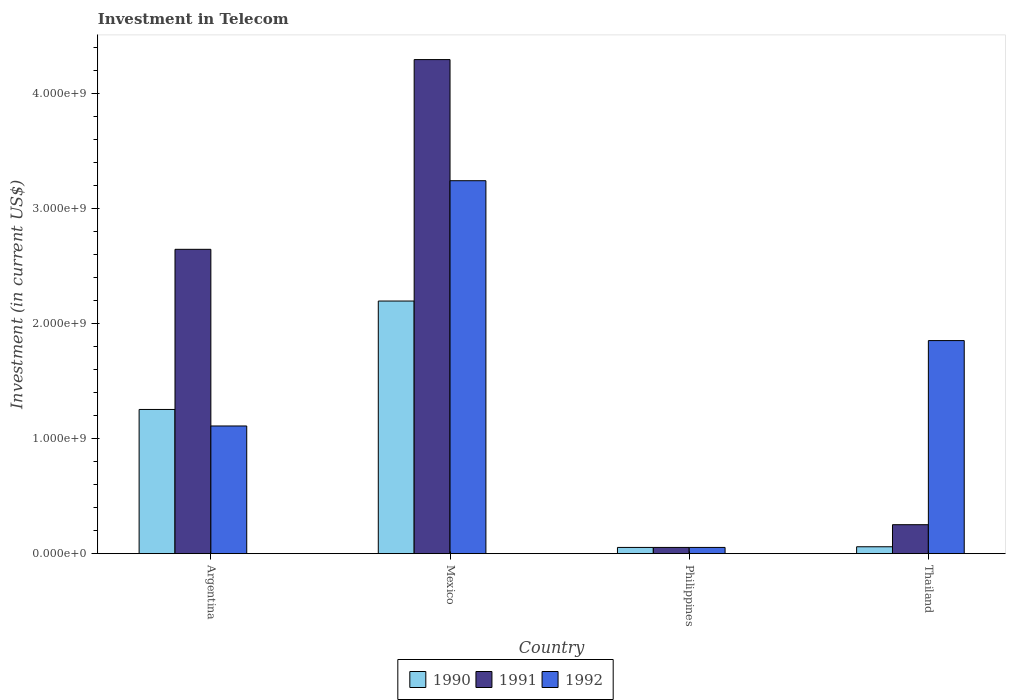How many groups of bars are there?
Offer a very short reply. 4. Are the number of bars per tick equal to the number of legend labels?
Provide a short and direct response. Yes. How many bars are there on the 1st tick from the right?
Offer a very short reply. 3. What is the label of the 4th group of bars from the left?
Offer a very short reply. Thailand. What is the amount invested in telecom in 1991 in Mexico?
Provide a short and direct response. 4.30e+09. Across all countries, what is the maximum amount invested in telecom in 1992?
Make the answer very short. 3.24e+09. Across all countries, what is the minimum amount invested in telecom in 1990?
Keep it short and to the point. 5.42e+07. In which country was the amount invested in telecom in 1991 maximum?
Provide a succinct answer. Mexico. In which country was the amount invested in telecom in 1992 minimum?
Keep it short and to the point. Philippines. What is the total amount invested in telecom in 1991 in the graph?
Give a very brief answer. 7.25e+09. What is the difference between the amount invested in telecom in 1990 in Philippines and that in Thailand?
Provide a short and direct response. -5.80e+06. What is the difference between the amount invested in telecom in 1992 in Thailand and the amount invested in telecom in 1990 in Argentina?
Offer a terse response. 5.99e+08. What is the average amount invested in telecom in 1990 per country?
Provide a short and direct response. 8.92e+08. What is the difference between the amount invested in telecom of/in 1990 and amount invested in telecom of/in 1991 in Mexico?
Your answer should be compact. -2.10e+09. What is the ratio of the amount invested in telecom in 1992 in Philippines to that in Thailand?
Your answer should be very brief. 0.03. Is the amount invested in telecom in 1992 in Argentina less than that in Philippines?
Make the answer very short. No. What is the difference between the highest and the second highest amount invested in telecom in 1991?
Offer a very short reply. 1.65e+09. What is the difference between the highest and the lowest amount invested in telecom in 1990?
Offer a very short reply. 2.14e+09. Is the sum of the amount invested in telecom in 1991 in Philippines and Thailand greater than the maximum amount invested in telecom in 1992 across all countries?
Give a very brief answer. No. What does the 2nd bar from the right in Argentina represents?
Your response must be concise. 1991. Is it the case that in every country, the sum of the amount invested in telecom in 1990 and amount invested in telecom in 1992 is greater than the amount invested in telecom in 1991?
Make the answer very short. No. Are all the bars in the graph horizontal?
Give a very brief answer. No. What is the difference between two consecutive major ticks on the Y-axis?
Your answer should be compact. 1.00e+09. Are the values on the major ticks of Y-axis written in scientific E-notation?
Make the answer very short. Yes. Does the graph contain any zero values?
Your answer should be compact. No. How are the legend labels stacked?
Provide a short and direct response. Horizontal. What is the title of the graph?
Your response must be concise. Investment in Telecom. What is the label or title of the X-axis?
Ensure brevity in your answer.  Country. What is the label or title of the Y-axis?
Make the answer very short. Investment (in current US$). What is the Investment (in current US$) of 1990 in Argentina?
Offer a very short reply. 1.25e+09. What is the Investment (in current US$) of 1991 in Argentina?
Ensure brevity in your answer.  2.65e+09. What is the Investment (in current US$) of 1992 in Argentina?
Offer a very short reply. 1.11e+09. What is the Investment (in current US$) of 1990 in Mexico?
Give a very brief answer. 2.20e+09. What is the Investment (in current US$) in 1991 in Mexico?
Ensure brevity in your answer.  4.30e+09. What is the Investment (in current US$) of 1992 in Mexico?
Your response must be concise. 3.24e+09. What is the Investment (in current US$) of 1990 in Philippines?
Offer a terse response. 5.42e+07. What is the Investment (in current US$) in 1991 in Philippines?
Your response must be concise. 5.42e+07. What is the Investment (in current US$) in 1992 in Philippines?
Offer a terse response. 5.42e+07. What is the Investment (in current US$) of 1990 in Thailand?
Keep it short and to the point. 6.00e+07. What is the Investment (in current US$) of 1991 in Thailand?
Keep it short and to the point. 2.52e+08. What is the Investment (in current US$) in 1992 in Thailand?
Make the answer very short. 1.85e+09. Across all countries, what is the maximum Investment (in current US$) of 1990?
Provide a short and direct response. 2.20e+09. Across all countries, what is the maximum Investment (in current US$) in 1991?
Make the answer very short. 4.30e+09. Across all countries, what is the maximum Investment (in current US$) in 1992?
Provide a short and direct response. 3.24e+09. Across all countries, what is the minimum Investment (in current US$) in 1990?
Make the answer very short. 5.42e+07. Across all countries, what is the minimum Investment (in current US$) in 1991?
Ensure brevity in your answer.  5.42e+07. Across all countries, what is the minimum Investment (in current US$) in 1992?
Ensure brevity in your answer.  5.42e+07. What is the total Investment (in current US$) of 1990 in the graph?
Keep it short and to the point. 3.57e+09. What is the total Investment (in current US$) of 1991 in the graph?
Your response must be concise. 7.25e+09. What is the total Investment (in current US$) in 1992 in the graph?
Your answer should be very brief. 6.26e+09. What is the difference between the Investment (in current US$) of 1990 in Argentina and that in Mexico?
Offer a very short reply. -9.43e+08. What is the difference between the Investment (in current US$) of 1991 in Argentina and that in Mexico?
Provide a succinct answer. -1.65e+09. What is the difference between the Investment (in current US$) in 1992 in Argentina and that in Mexico?
Ensure brevity in your answer.  -2.13e+09. What is the difference between the Investment (in current US$) of 1990 in Argentina and that in Philippines?
Provide a short and direct response. 1.20e+09. What is the difference between the Investment (in current US$) in 1991 in Argentina and that in Philippines?
Offer a terse response. 2.59e+09. What is the difference between the Investment (in current US$) in 1992 in Argentina and that in Philippines?
Your answer should be compact. 1.06e+09. What is the difference between the Investment (in current US$) of 1990 in Argentina and that in Thailand?
Provide a short and direct response. 1.19e+09. What is the difference between the Investment (in current US$) in 1991 in Argentina and that in Thailand?
Your answer should be very brief. 2.40e+09. What is the difference between the Investment (in current US$) in 1992 in Argentina and that in Thailand?
Offer a very short reply. -7.43e+08. What is the difference between the Investment (in current US$) of 1990 in Mexico and that in Philippines?
Make the answer very short. 2.14e+09. What is the difference between the Investment (in current US$) in 1991 in Mexico and that in Philippines?
Your answer should be very brief. 4.24e+09. What is the difference between the Investment (in current US$) of 1992 in Mexico and that in Philippines?
Your answer should be compact. 3.19e+09. What is the difference between the Investment (in current US$) in 1990 in Mexico and that in Thailand?
Keep it short and to the point. 2.14e+09. What is the difference between the Investment (in current US$) of 1991 in Mexico and that in Thailand?
Provide a succinct answer. 4.05e+09. What is the difference between the Investment (in current US$) of 1992 in Mexico and that in Thailand?
Your answer should be compact. 1.39e+09. What is the difference between the Investment (in current US$) of 1990 in Philippines and that in Thailand?
Offer a terse response. -5.80e+06. What is the difference between the Investment (in current US$) of 1991 in Philippines and that in Thailand?
Provide a succinct answer. -1.98e+08. What is the difference between the Investment (in current US$) of 1992 in Philippines and that in Thailand?
Keep it short and to the point. -1.80e+09. What is the difference between the Investment (in current US$) of 1990 in Argentina and the Investment (in current US$) of 1991 in Mexico?
Give a very brief answer. -3.04e+09. What is the difference between the Investment (in current US$) of 1990 in Argentina and the Investment (in current US$) of 1992 in Mexico?
Keep it short and to the point. -1.99e+09. What is the difference between the Investment (in current US$) of 1991 in Argentina and the Investment (in current US$) of 1992 in Mexico?
Make the answer very short. -5.97e+08. What is the difference between the Investment (in current US$) in 1990 in Argentina and the Investment (in current US$) in 1991 in Philippines?
Give a very brief answer. 1.20e+09. What is the difference between the Investment (in current US$) of 1990 in Argentina and the Investment (in current US$) of 1992 in Philippines?
Provide a short and direct response. 1.20e+09. What is the difference between the Investment (in current US$) in 1991 in Argentina and the Investment (in current US$) in 1992 in Philippines?
Provide a short and direct response. 2.59e+09. What is the difference between the Investment (in current US$) in 1990 in Argentina and the Investment (in current US$) in 1991 in Thailand?
Provide a succinct answer. 1.00e+09. What is the difference between the Investment (in current US$) in 1990 in Argentina and the Investment (in current US$) in 1992 in Thailand?
Provide a short and direct response. -5.99e+08. What is the difference between the Investment (in current US$) in 1991 in Argentina and the Investment (in current US$) in 1992 in Thailand?
Your answer should be compact. 7.94e+08. What is the difference between the Investment (in current US$) in 1990 in Mexico and the Investment (in current US$) in 1991 in Philippines?
Offer a terse response. 2.14e+09. What is the difference between the Investment (in current US$) in 1990 in Mexico and the Investment (in current US$) in 1992 in Philippines?
Provide a succinct answer. 2.14e+09. What is the difference between the Investment (in current US$) in 1991 in Mexico and the Investment (in current US$) in 1992 in Philippines?
Offer a terse response. 4.24e+09. What is the difference between the Investment (in current US$) of 1990 in Mexico and the Investment (in current US$) of 1991 in Thailand?
Offer a terse response. 1.95e+09. What is the difference between the Investment (in current US$) in 1990 in Mexico and the Investment (in current US$) in 1992 in Thailand?
Provide a short and direct response. 3.44e+08. What is the difference between the Investment (in current US$) in 1991 in Mexico and the Investment (in current US$) in 1992 in Thailand?
Your answer should be very brief. 2.44e+09. What is the difference between the Investment (in current US$) of 1990 in Philippines and the Investment (in current US$) of 1991 in Thailand?
Offer a terse response. -1.98e+08. What is the difference between the Investment (in current US$) of 1990 in Philippines and the Investment (in current US$) of 1992 in Thailand?
Offer a very short reply. -1.80e+09. What is the difference between the Investment (in current US$) in 1991 in Philippines and the Investment (in current US$) in 1992 in Thailand?
Provide a succinct answer. -1.80e+09. What is the average Investment (in current US$) of 1990 per country?
Your answer should be compact. 8.92e+08. What is the average Investment (in current US$) in 1991 per country?
Offer a terse response. 1.81e+09. What is the average Investment (in current US$) of 1992 per country?
Your response must be concise. 1.57e+09. What is the difference between the Investment (in current US$) of 1990 and Investment (in current US$) of 1991 in Argentina?
Ensure brevity in your answer.  -1.39e+09. What is the difference between the Investment (in current US$) of 1990 and Investment (in current US$) of 1992 in Argentina?
Your answer should be compact. 1.44e+08. What is the difference between the Investment (in current US$) in 1991 and Investment (in current US$) in 1992 in Argentina?
Your response must be concise. 1.54e+09. What is the difference between the Investment (in current US$) in 1990 and Investment (in current US$) in 1991 in Mexico?
Give a very brief answer. -2.10e+09. What is the difference between the Investment (in current US$) of 1990 and Investment (in current US$) of 1992 in Mexico?
Offer a terse response. -1.05e+09. What is the difference between the Investment (in current US$) in 1991 and Investment (in current US$) in 1992 in Mexico?
Offer a very short reply. 1.05e+09. What is the difference between the Investment (in current US$) of 1990 and Investment (in current US$) of 1991 in Philippines?
Offer a terse response. 0. What is the difference between the Investment (in current US$) of 1990 and Investment (in current US$) of 1992 in Philippines?
Your answer should be very brief. 0. What is the difference between the Investment (in current US$) of 1991 and Investment (in current US$) of 1992 in Philippines?
Your response must be concise. 0. What is the difference between the Investment (in current US$) of 1990 and Investment (in current US$) of 1991 in Thailand?
Give a very brief answer. -1.92e+08. What is the difference between the Investment (in current US$) in 1990 and Investment (in current US$) in 1992 in Thailand?
Provide a short and direct response. -1.79e+09. What is the difference between the Investment (in current US$) of 1991 and Investment (in current US$) of 1992 in Thailand?
Ensure brevity in your answer.  -1.60e+09. What is the ratio of the Investment (in current US$) of 1990 in Argentina to that in Mexico?
Offer a terse response. 0.57. What is the ratio of the Investment (in current US$) of 1991 in Argentina to that in Mexico?
Provide a short and direct response. 0.62. What is the ratio of the Investment (in current US$) in 1992 in Argentina to that in Mexico?
Your response must be concise. 0.34. What is the ratio of the Investment (in current US$) of 1990 in Argentina to that in Philippines?
Your answer should be very brief. 23.15. What is the ratio of the Investment (in current US$) in 1991 in Argentina to that in Philippines?
Make the answer very short. 48.86. What is the ratio of the Investment (in current US$) of 1992 in Argentina to that in Philippines?
Make the answer very short. 20.5. What is the ratio of the Investment (in current US$) in 1990 in Argentina to that in Thailand?
Offer a very short reply. 20.91. What is the ratio of the Investment (in current US$) of 1991 in Argentina to that in Thailand?
Provide a short and direct response. 10.51. What is the ratio of the Investment (in current US$) in 1992 in Argentina to that in Thailand?
Provide a succinct answer. 0.6. What is the ratio of the Investment (in current US$) of 1990 in Mexico to that in Philippines?
Offer a terse response. 40.55. What is the ratio of the Investment (in current US$) of 1991 in Mexico to that in Philippines?
Provide a short and direct response. 79.32. What is the ratio of the Investment (in current US$) of 1992 in Mexico to that in Philippines?
Your response must be concise. 59.87. What is the ratio of the Investment (in current US$) of 1990 in Mexico to that in Thailand?
Your answer should be very brief. 36.63. What is the ratio of the Investment (in current US$) in 1991 in Mexico to that in Thailand?
Offer a terse response. 17.06. What is the ratio of the Investment (in current US$) in 1992 in Mexico to that in Thailand?
Your answer should be very brief. 1.75. What is the ratio of the Investment (in current US$) of 1990 in Philippines to that in Thailand?
Give a very brief answer. 0.9. What is the ratio of the Investment (in current US$) in 1991 in Philippines to that in Thailand?
Your answer should be compact. 0.22. What is the ratio of the Investment (in current US$) in 1992 in Philippines to that in Thailand?
Offer a terse response. 0.03. What is the difference between the highest and the second highest Investment (in current US$) in 1990?
Provide a succinct answer. 9.43e+08. What is the difference between the highest and the second highest Investment (in current US$) in 1991?
Make the answer very short. 1.65e+09. What is the difference between the highest and the second highest Investment (in current US$) of 1992?
Make the answer very short. 1.39e+09. What is the difference between the highest and the lowest Investment (in current US$) of 1990?
Your answer should be very brief. 2.14e+09. What is the difference between the highest and the lowest Investment (in current US$) in 1991?
Keep it short and to the point. 4.24e+09. What is the difference between the highest and the lowest Investment (in current US$) of 1992?
Offer a terse response. 3.19e+09. 